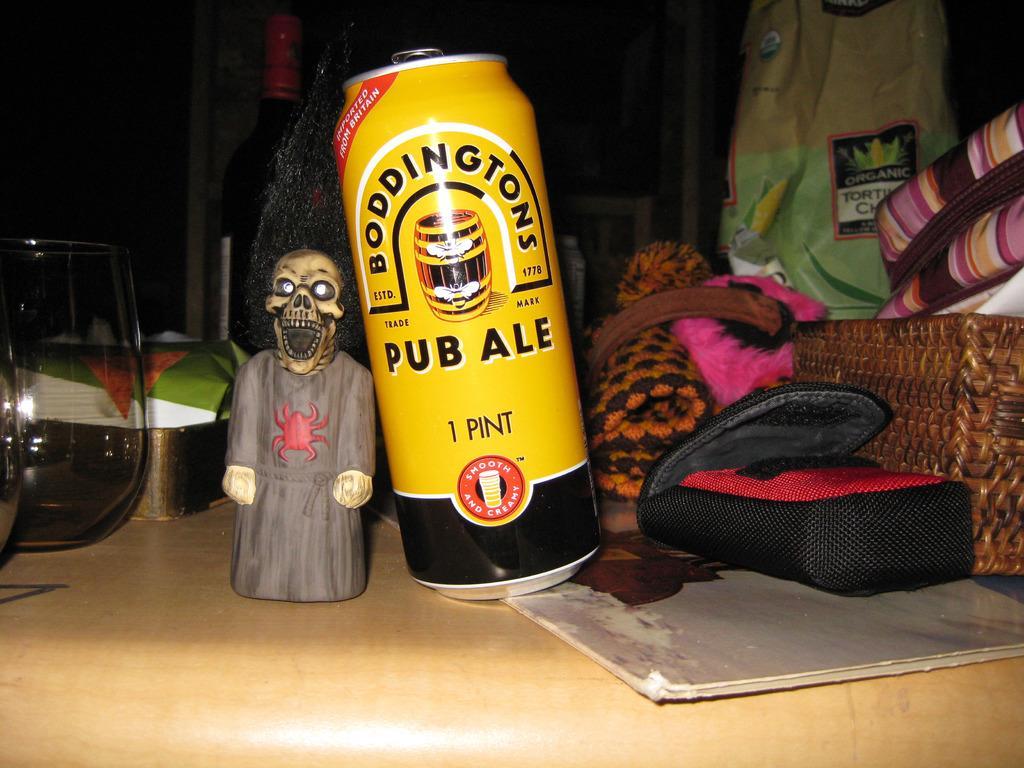Can you describe this image briefly? In this image there is a coke can on the table having big, glasses, toy, basket and few objects. Right side there is a basket having bags and few objects. 